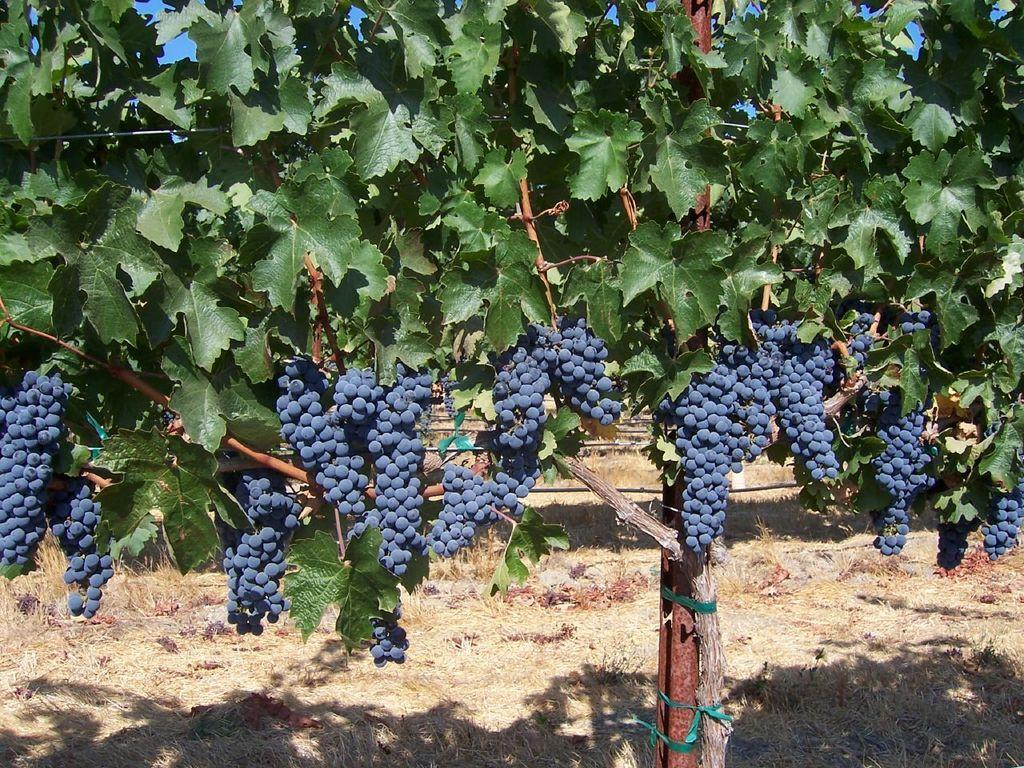What type of plant can be seen in the image? There is a tree in the image. What is growing on the tree? There are grapes on the tree. What other object is present in the image? There is a metal rod in the image. What shape is the question mark on the tree? There is no question mark present on the tree; it is a tree with grapes growing on it. 